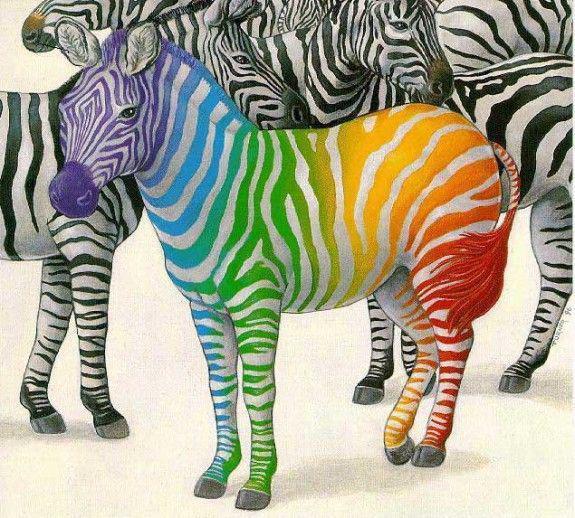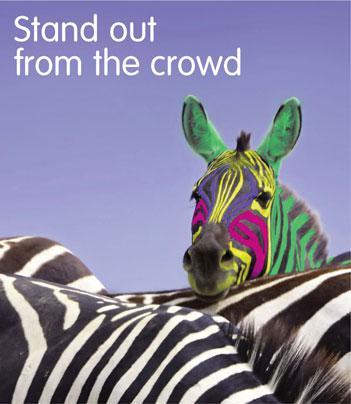The first image is the image on the left, the second image is the image on the right. Analyze the images presented: Is the assertion "The left image includes one zebra with only violet tint added, standing on the far right with its body turned leftward." valid? Answer yes or no. No. The first image is the image on the left, the second image is the image on the right. Considering the images on both sides, is "In the left image, there is one zebra with black and purple stripes." valid? Answer yes or no. No. 